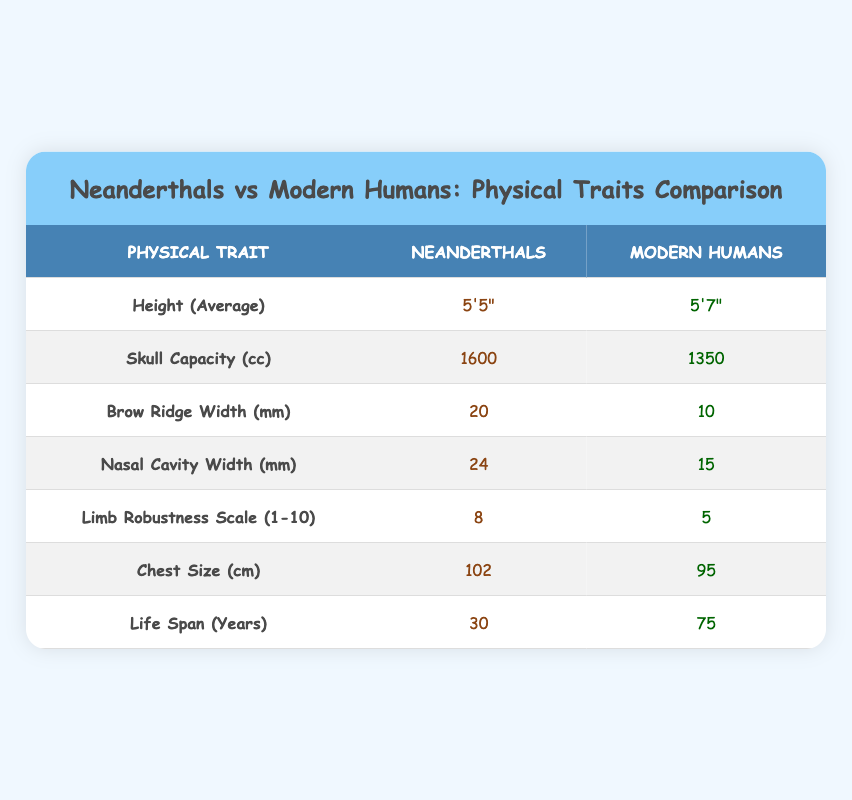What is the average height of Neanderthals? According to the table, the average height of Neanderthals is listed as 5'5".
Answer: 5'5" What is the skull capacity of modern humans? The table shows that the skull capacity of modern humans is 1350 cc.
Answer: 1350 cc True or false: Neanderthals have a larger brow ridge width than modern humans. The table indicates that Neanderthals have a brow ridge width of 20 mm, while modern humans have a width of 10 mm. Since 20 mm is greater than 10 mm, the statement is true.
Answer: True What is the difference in life span between Neanderthals and modern humans? Neanderthals have a life span of 30 years and modern humans have a life span of 75 years. The difference can be calculated by subtracting 30 from 75, which gives 45 years.
Answer: 45 years What is the average chest size of both Neanderthals and modern humans combined? From the table, Neanderthals have a chest size of 102 cm and modern humans have a chest size of 95 cm. To find the average, first sum the two chest sizes: 102 + 95 = 197 cm. Then divide by 2 for the average: 197 / 2 = 98.5 cm.
Answer: 98.5 cm True or false: Neanderthals have a greater limb robustness scale than modern humans. The limb robustness scale for Neanderthals is 8, while for modern humans, it is 5. Since 8 is greater than 5, the statement is true.
Answer: True What is the ratio of skull capacity between Neanderthals and modern humans? Neanderthals have a skull capacity of 1600 cc and modern humans have 1350 cc. To find the ratio, divide 1600 by 1350, which gives approximately 1.19.
Answer: 1.19 What is the average width of the nasal cavity between both groups? The nasal cavity width for Neanderthals is 24 mm and for modern humans, it is 15 mm. To find the average, sum the two widths: 24 + 15 = 39 mm. Then divide by 2: 39 / 2 = 19.5 mm.
Answer: 19.5 mm How much taller are modern humans compared to Neanderthals? Modern humans are 5'7" tall while Neanderthals are 5'5" tall. To find the difference, convert both heights into inches: 5'7" is 67 inches and 5'5" is 65 inches. The difference is 67 - 65 = 2 inches.
Answer: 2 inches 